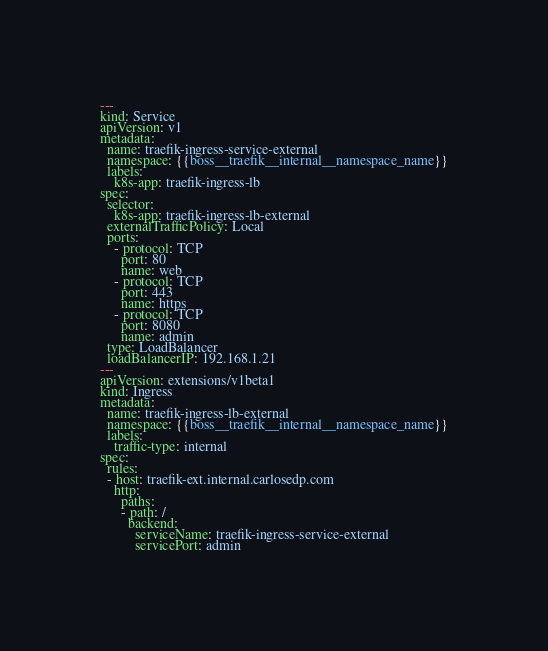Convert code to text. <code><loc_0><loc_0><loc_500><loc_500><_YAML_>---
kind: Service
apiVersion: v1
metadata:
  name: traefik-ingress-service-external
  namespace: {{boss__traefik__internal__namespace_name}}
  labels:
    k8s-app: traefik-ingress-lb
spec:
  selector:
    k8s-app: traefik-ingress-lb-external
  externalTrafficPolicy: Local
  ports:
    - protocol: TCP
      port: 80
      name: web
    - protocol: TCP
      port: 443
      name: https
    - protocol: TCP
      port: 8080
      name: admin
  type: LoadBalancer
  loadBalancerIP: 192.168.1.21
---
apiVersion: extensions/v1beta1
kind: Ingress
metadata:
  name: traefik-ingress-lb-external
  namespace: {{boss__traefik__internal__namespace_name}}
  labels:
    traffic-type: internal
spec:
  rules:
  - host: traefik-ext.internal.carlosedp.com
    http:
      paths:
      - path: /
        backend:
          serviceName: traefik-ingress-service-external
          servicePort: admin

</code> 